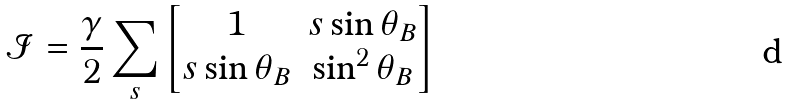<formula> <loc_0><loc_0><loc_500><loc_500>\mathcal { I } & = \frac { \gamma } { 2 } \sum _ { s } \begin{bmatrix} 1 & s \sin \theta _ { B } \\ s \sin \theta _ { B } & \sin ^ { 2 } \theta _ { B } \end{bmatrix} \\</formula> 